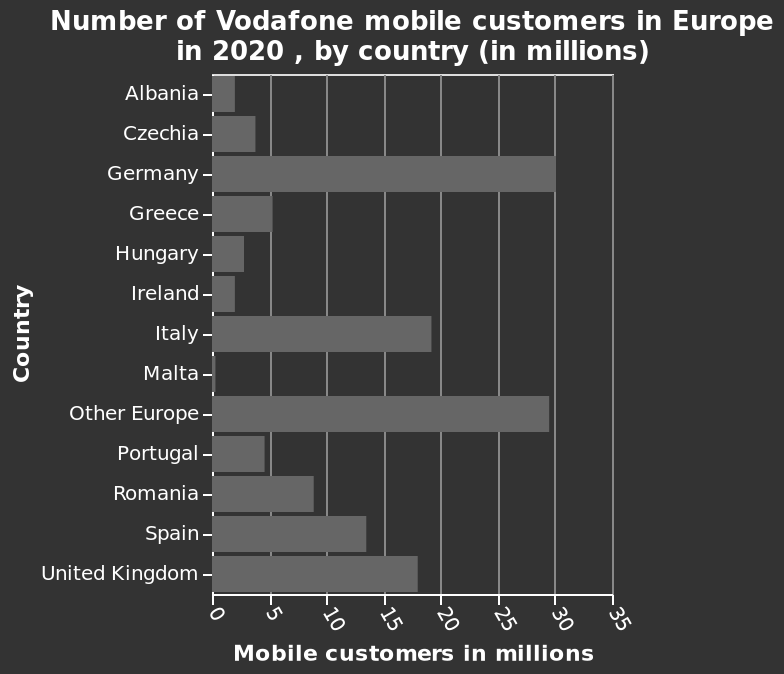<image>
Which country had the second-highest number of Vodafone customers in Europe in 2020?  Other Europe is a close second in terms of Vodafone customers. 